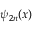Convert formula to latex. <formula><loc_0><loc_0><loc_500><loc_500>\psi _ { 2 n } ( x )</formula> 